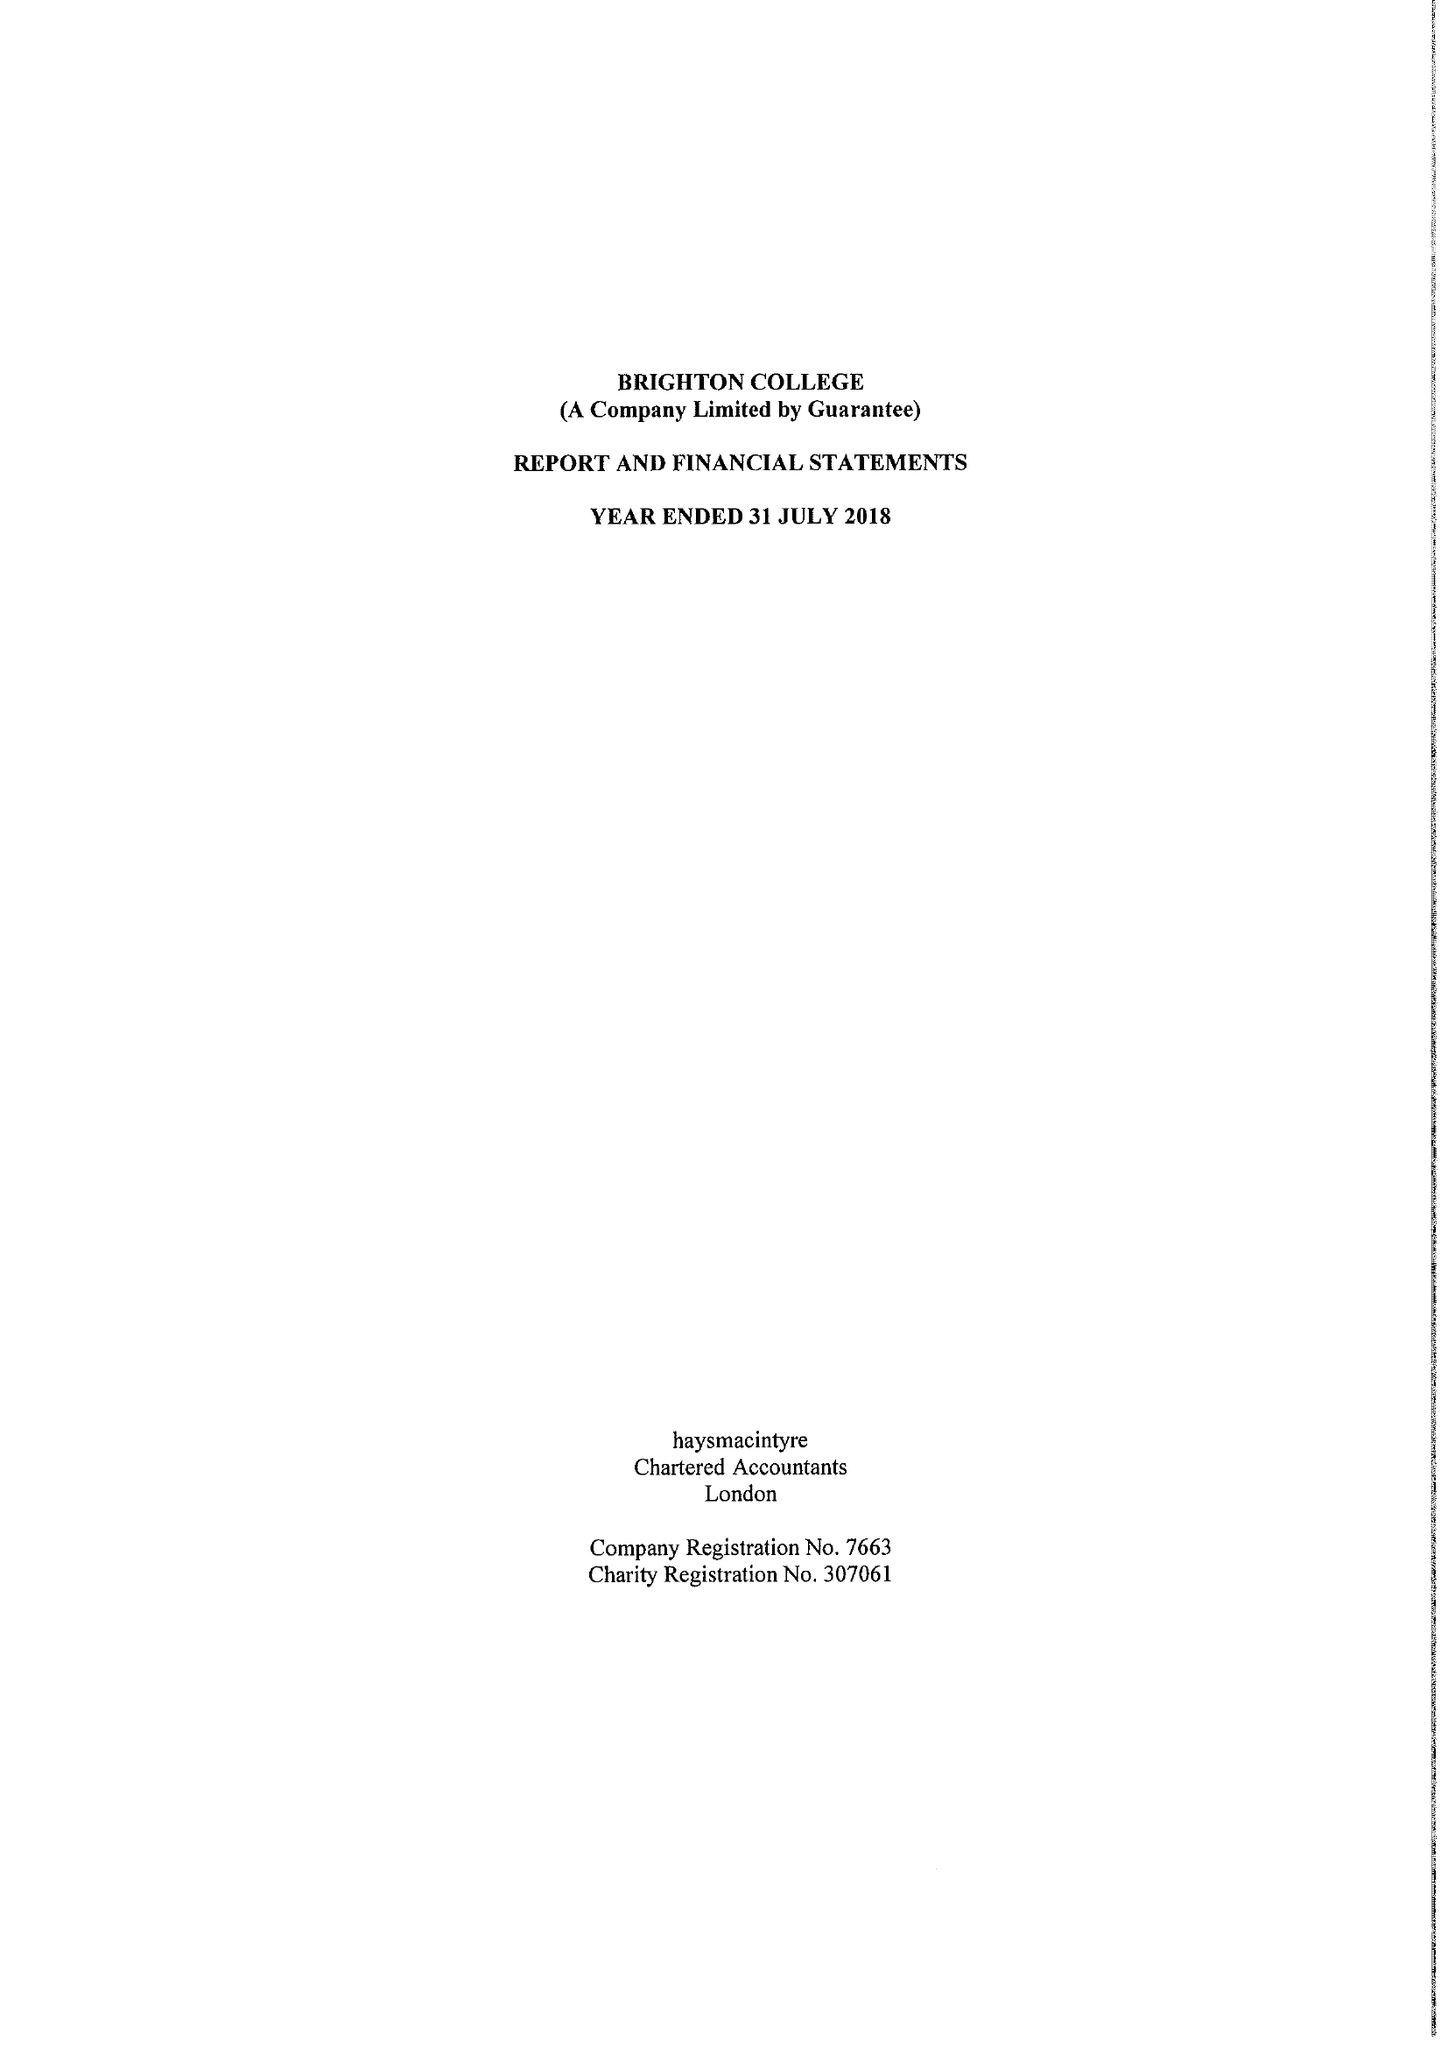What is the value for the address__postcode?
Answer the question using a single word or phrase. BN2 0AL 